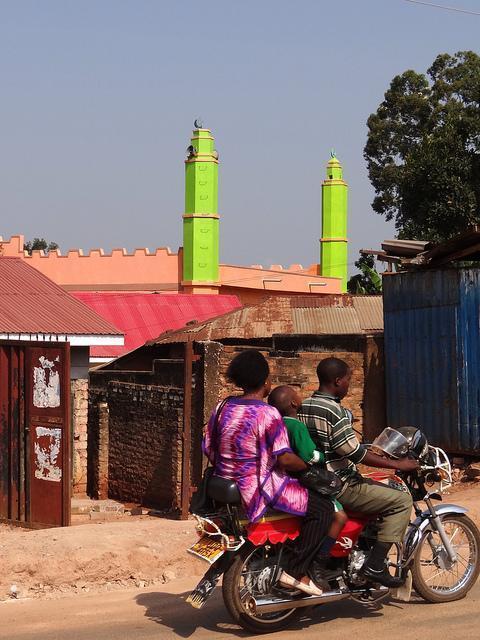Why are three people on the bike?
Indicate the correct response by choosing from the four available options to answer the question.
Options: Dare, bet, cheap transportation, in hurry. Cheap transportation. 